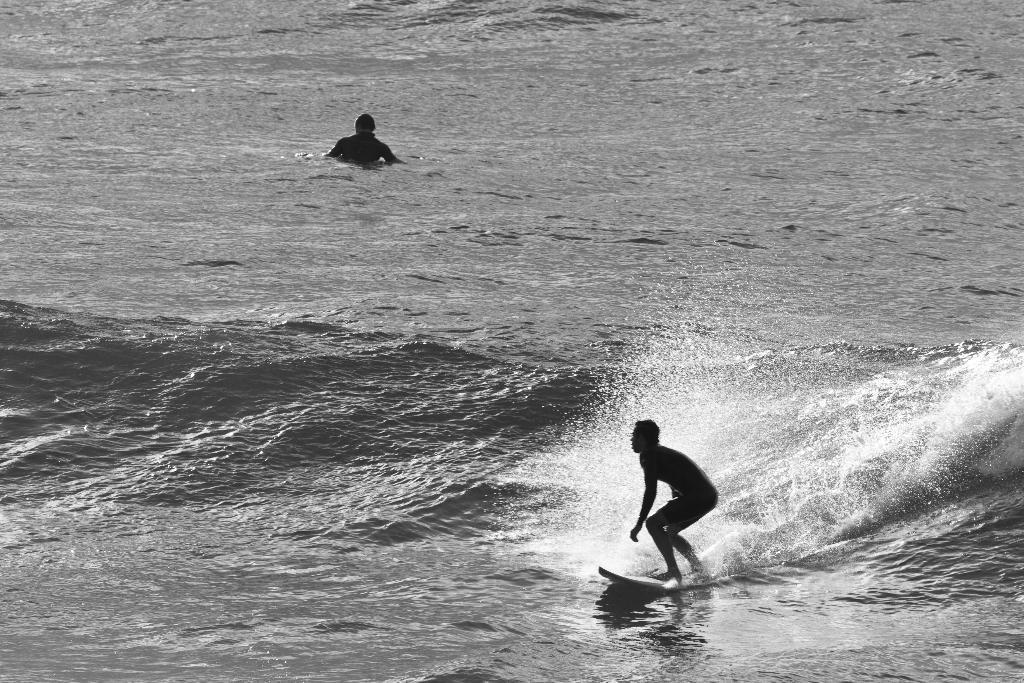Can you describe this image briefly? In this image, we can see a person is surfing with a surfboard on the water. Here we can see a person in the water. 